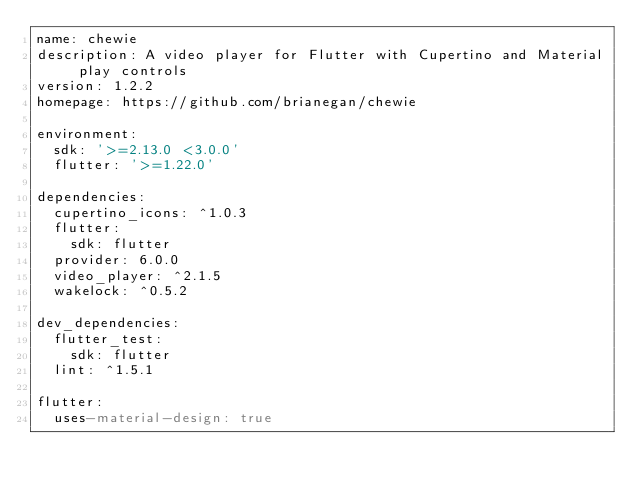<code> <loc_0><loc_0><loc_500><loc_500><_YAML_>name: chewie
description: A video player for Flutter with Cupertino and Material play controls
version: 1.2.2
homepage: https://github.com/brianegan/chewie

environment:
  sdk: '>=2.13.0 <3.0.0'
  flutter: '>=1.22.0'

dependencies:
  cupertino_icons: ^1.0.3
  flutter:
    sdk: flutter
  provider: 6.0.0
  video_player: ^2.1.5
  wakelock: ^0.5.2

dev_dependencies:
  flutter_test:
    sdk: flutter
  lint: ^1.5.1

flutter:
  uses-material-design: true
</code> 